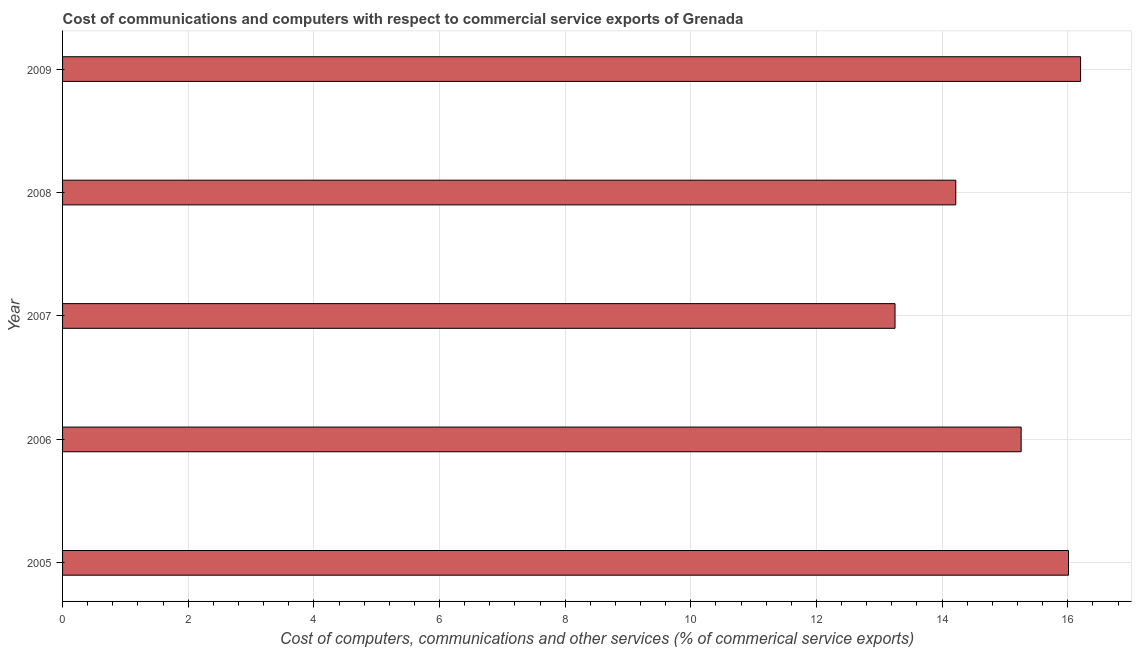What is the title of the graph?
Offer a terse response. Cost of communications and computers with respect to commercial service exports of Grenada. What is the label or title of the X-axis?
Your answer should be very brief. Cost of computers, communications and other services (% of commerical service exports). What is the label or title of the Y-axis?
Keep it short and to the point. Year. What is the  computer and other services in 2007?
Give a very brief answer. 13.25. Across all years, what is the maximum cost of communications?
Ensure brevity in your answer.  16.2. Across all years, what is the minimum  computer and other services?
Provide a short and direct response. 13.25. In which year was the  computer and other services maximum?
Provide a succinct answer. 2009. In which year was the cost of communications minimum?
Offer a very short reply. 2007. What is the sum of the cost of communications?
Offer a very short reply. 74.94. What is the difference between the  computer and other services in 2005 and 2009?
Give a very brief answer. -0.19. What is the average cost of communications per year?
Provide a short and direct response. 14.99. What is the median  computer and other services?
Offer a very short reply. 15.26. In how many years, is the  computer and other services greater than 12.8 %?
Your answer should be compact. 5. Do a majority of the years between 2009 and 2005 (inclusive) have cost of communications greater than 1.2 %?
Make the answer very short. Yes. What is the ratio of the  computer and other services in 2006 to that in 2009?
Your answer should be compact. 0.94. Is the  computer and other services in 2005 less than that in 2009?
Give a very brief answer. Yes. Is the difference between the  computer and other services in 2005 and 2006 greater than the difference between any two years?
Ensure brevity in your answer.  No. What is the difference between the highest and the second highest cost of communications?
Keep it short and to the point. 0.19. Is the sum of the cost of communications in 2007 and 2008 greater than the maximum cost of communications across all years?
Your answer should be compact. Yes. What is the difference between the highest and the lowest cost of communications?
Provide a succinct answer. 2.95. How many bars are there?
Provide a short and direct response. 5. What is the Cost of computers, communications and other services (% of commerical service exports) of 2005?
Your response must be concise. 16.01. What is the Cost of computers, communications and other services (% of commerical service exports) of 2006?
Offer a very short reply. 15.26. What is the Cost of computers, communications and other services (% of commerical service exports) of 2007?
Your response must be concise. 13.25. What is the Cost of computers, communications and other services (% of commerical service exports) in 2008?
Offer a terse response. 14.22. What is the Cost of computers, communications and other services (% of commerical service exports) of 2009?
Offer a very short reply. 16.2. What is the difference between the Cost of computers, communications and other services (% of commerical service exports) in 2005 and 2006?
Keep it short and to the point. 0.75. What is the difference between the Cost of computers, communications and other services (% of commerical service exports) in 2005 and 2007?
Ensure brevity in your answer.  2.76. What is the difference between the Cost of computers, communications and other services (% of commerical service exports) in 2005 and 2008?
Offer a terse response. 1.79. What is the difference between the Cost of computers, communications and other services (% of commerical service exports) in 2005 and 2009?
Your answer should be compact. -0.19. What is the difference between the Cost of computers, communications and other services (% of commerical service exports) in 2006 and 2007?
Your answer should be compact. 2.01. What is the difference between the Cost of computers, communications and other services (% of commerical service exports) in 2006 and 2008?
Provide a short and direct response. 1.04. What is the difference between the Cost of computers, communications and other services (% of commerical service exports) in 2006 and 2009?
Your response must be concise. -0.95. What is the difference between the Cost of computers, communications and other services (% of commerical service exports) in 2007 and 2008?
Make the answer very short. -0.97. What is the difference between the Cost of computers, communications and other services (% of commerical service exports) in 2007 and 2009?
Your answer should be compact. -2.95. What is the difference between the Cost of computers, communications and other services (% of commerical service exports) in 2008 and 2009?
Ensure brevity in your answer.  -1.99. What is the ratio of the Cost of computers, communications and other services (% of commerical service exports) in 2005 to that in 2006?
Your answer should be compact. 1.05. What is the ratio of the Cost of computers, communications and other services (% of commerical service exports) in 2005 to that in 2007?
Ensure brevity in your answer.  1.21. What is the ratio of the Cost of computers, communications and other services (% of commerical service exports) in 2005 to that in 2008?
Keep it short and to the point. 1.13. What is the ratio of the Cost of computers, communications and other services (% of commerical service exports) in 2006 to that in 2007?
Make the answer very short. 1.15. What is the ratio of the Cost of computers, communications and other services (% of commerical service exports) in 2006 to that in 2008?
Ensure brevity in your answer.  1.07. What is the ratio of the Cost of computers, communications and other services (% of commerical service exports) in 2006 to that in 2009?
Ensure brevity in your answer.  0.94. What is the ratio of the Cost of computers, communications and other services (% of commerical service exports) in 2007 to that in 2008?
Your answer should be compact. 0.93. What is the ratio of the Cost of computers, communications and other services (% of commerical service exports) in 2007 to that in 2009?
Your answer should be compact. 0.82. What is the ratio of the Cost of computers, communications and other services (% of commerical service exports) in 2008 to that in 2009?
Provide a short and direct response. 0.88. 